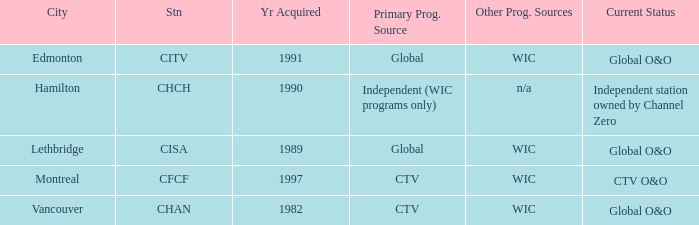Which station is located in edmonton CITV. 